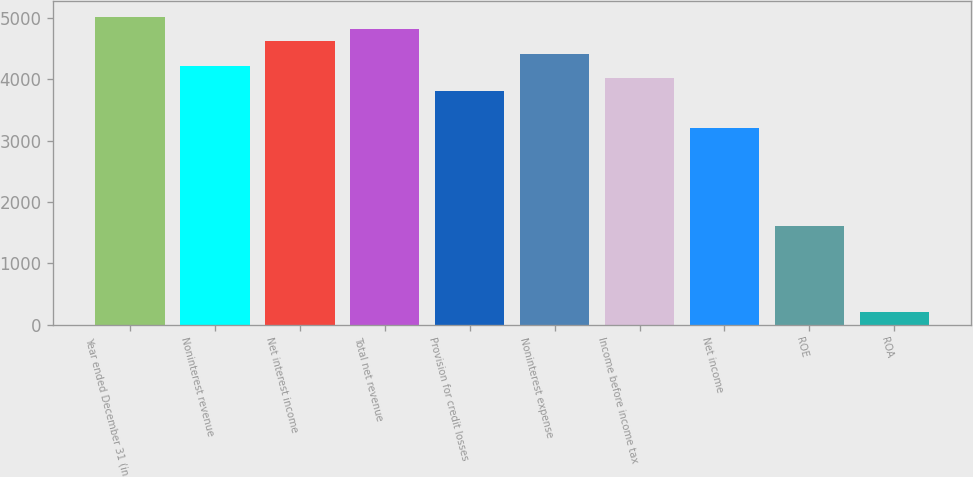Convert chart to OTSL. <chart><loc_0><loc_0><loc_500><loc_500><bar_chart><fcel>Year ended December 31 (in<fcel>Noninterest revenue<fcel>Net interest income<fcel>Total net revenue<fcel>Provision for credit losses<fcel>Noninterest expense<fcel>Income before income tax<fcel>Net income<fcel>ROE<fcel>ROA<nl><fcel>5017.05<fcel>4214.37<fcel>4615.71<fcel>4816.38<fcel>3813.03<fcel>4415.04<fcel>4013.7<fcel>3211.02<fcel>1605.66<fcel>200.97<nl></chart> 